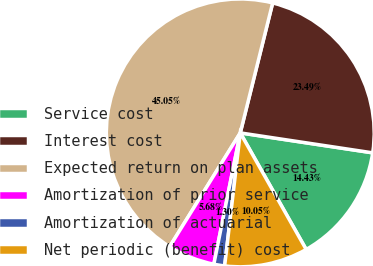Convert chart to OTSL. <chart><loc_0><loc_0><loc_500><loc_500><pie_chart><fcel>Service cost<fcel>Interest cost<fcel>Expected return on plan assets<fcel>Amortization of prior service<fcel>Amortization of actuarial<fcel>Net periodic (benefit) cost<nl><fcel>14.43%<fcel>23.49%<fcel>45.05%<fcel>5.68%<fcel>1.3%<fcel>10.05%<nl></chart> 